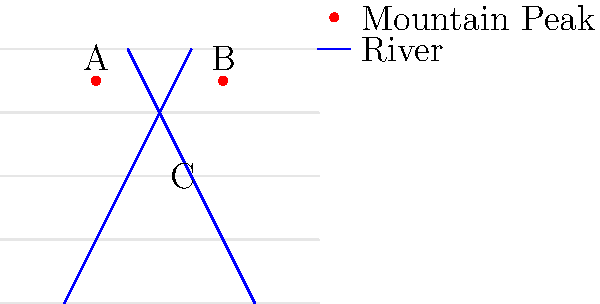Based on the topographic map of a region in Provence, which geographical feature is most likely represented by point C? To determine the geographical feature represented by point C, let's analyze the topographic map step-by-step:

1. Observe the contour lines: The map shows parallel, curved lines which represent elevation. Closer lines indicate steeper terrain.

2. Identify the mountain peaks: Points A and B are marked with red dots and are located at higher elevations, representing mountain peaks.

3. Locate the rivers: Two blue lines converge towards point C, representing rivers flowing from higher to lower elevations.

4. Analyze point C's location: It is situated at the convergence of the two rivers, in a relatively flat area between the mountain peaks.

5. Consider the typical geography of Provence: The region is known for its mountainous terrain interspersed with valleys and river systems.

6. Conclude based on the evidence: Given that point C is at the meeting point of two rivers in a flatter area between mountains, it most likely represents a valley or a river confluence.

In the context of Provence's geography, this feature is most accurately described as a valley, specifically a river valley formed by the convergence of two mountain streams.
Answer: Valley 